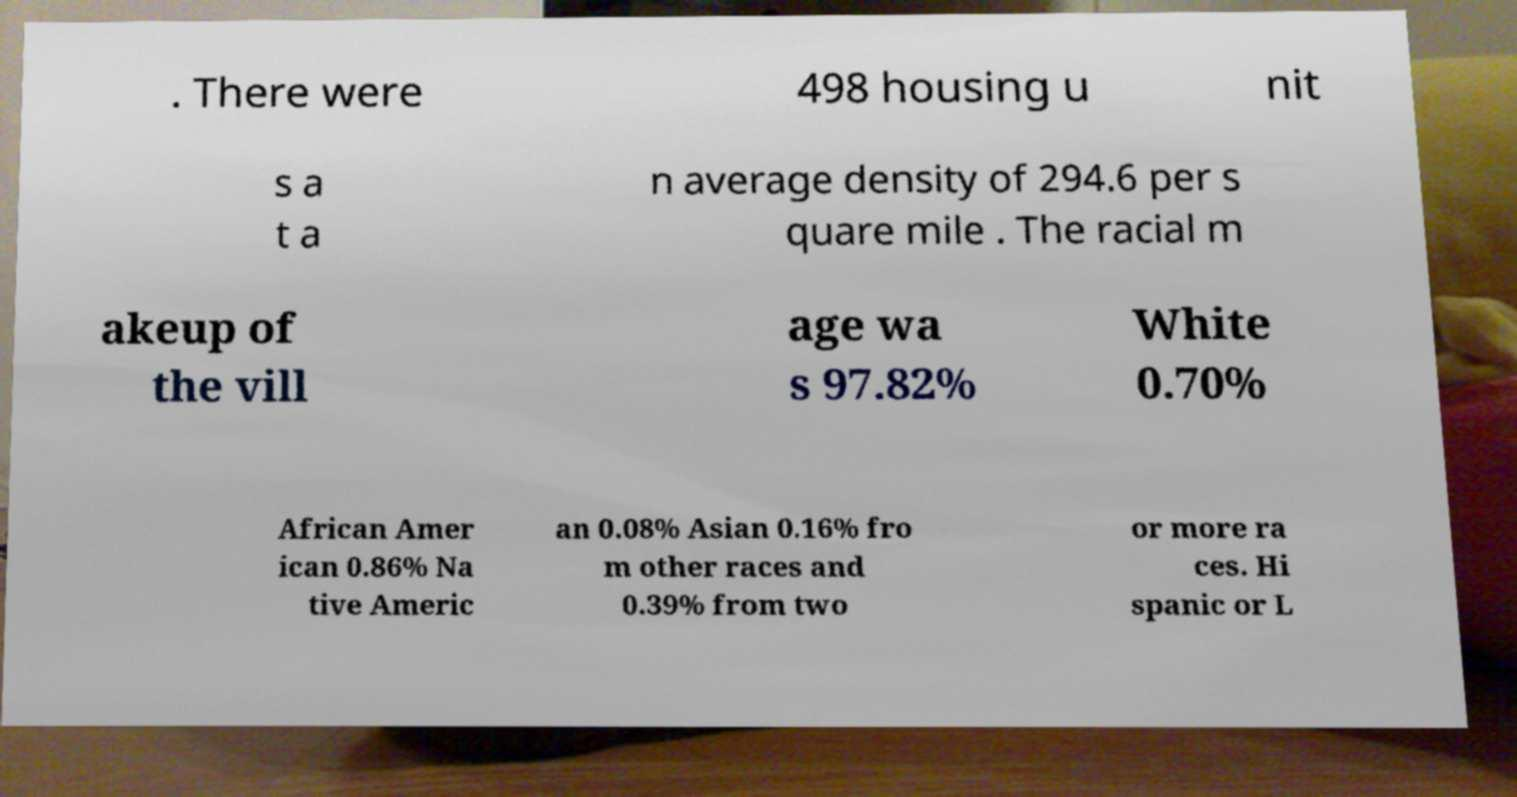For documentation purposes, I need the text within this image transcribed. Could you provide that? . There were 498 housing u nit s a t a n average density of 294.6 per s quare mile . The racial m akeup of the vill age wa s 97.82% White 0.70% African Amer ican 0.86% Na tive Americ an 0.08% Asian 0.16% fro m other races and 0.39% from two or more ra ces. Hi spanic or L 